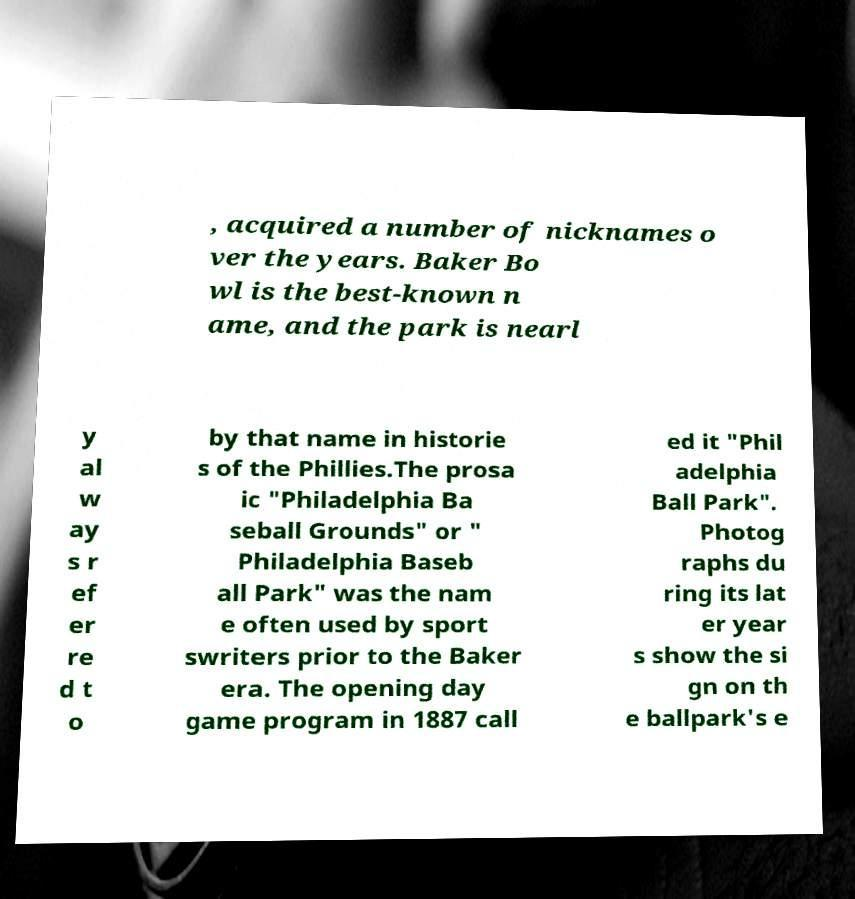Please read and relay the text visible in this image. What does it say? , acquired a number of nicknames o ver the years. Baker Bo wl is the best-known n ame, and the park is nearl y al w ay s r ef er re d t o by that name in historie s of the Phillies.The prosa ic "Philadelphia Ba seball Grounds" or " Philadelphia Baseb all Park" was the nam e often used by sport swriters prior to the Baker era. The opening day game program in 1887 call ed it "Phil adelphia Ball Park". Photog raphs du ring its lat er year s show the si gn on th e ballpark's e 